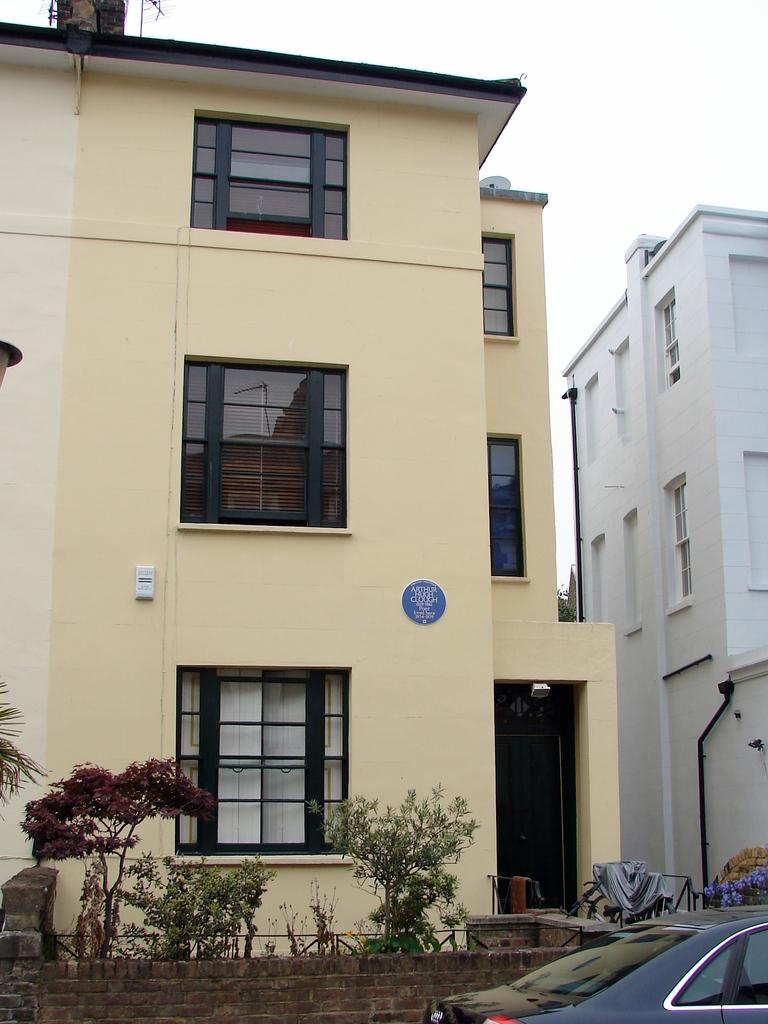What is the main subject of the image? There is a car in the image. What else can be seen in the image besides the car? There are plants, a wall, buildings with windows, curtains, cloth, and pipes visible in the image. Can you describe the background of the image? The sky is visible in the background of the image. What type of quilt is being used to cover the car in the image? There is no quilt present in the image, and the car is not covered by any fabric. Can you see a hammer being used to fix the pipes in the image? There is no hammer visible in the image, and the purpose of the pipes is not indicated. 